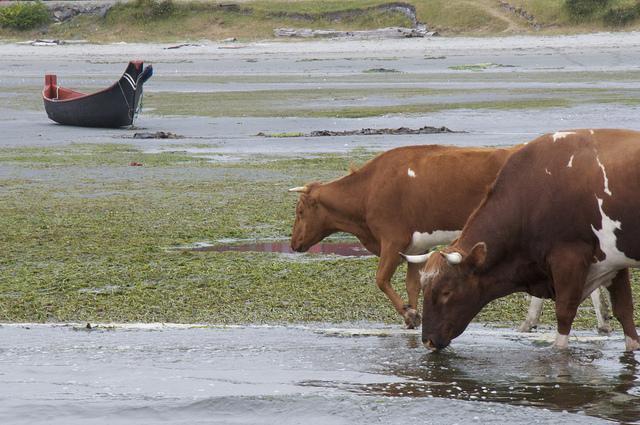How many cows can be seen?
Give a very brief answer. 2. 